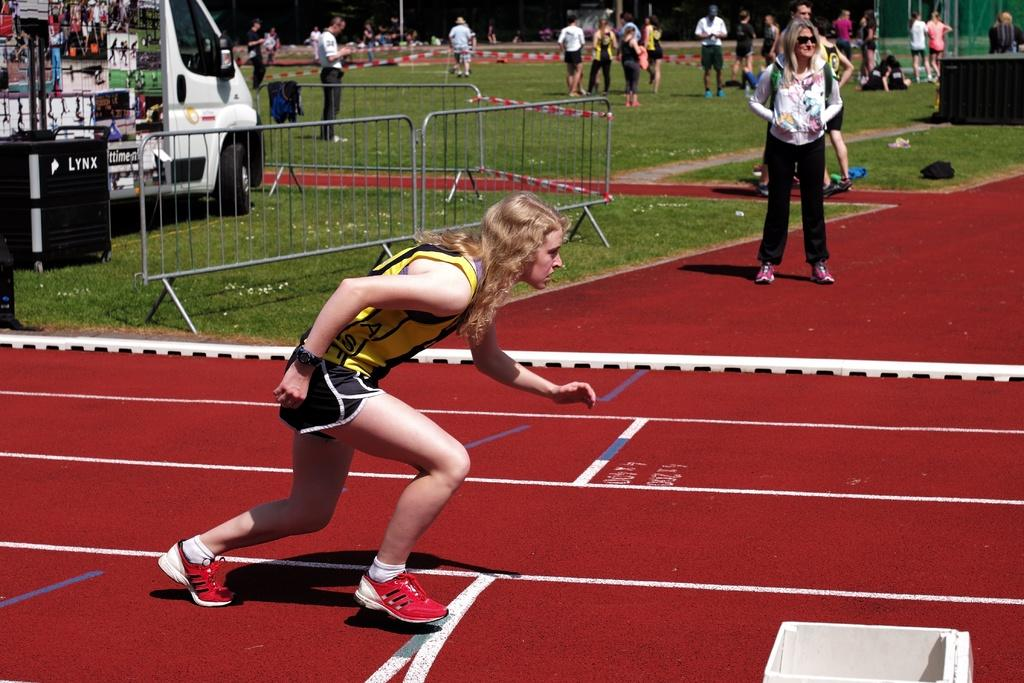<image>
Give a short and clear explanation of the subsequent image. a lady in yellow has the letter A on her jersey 